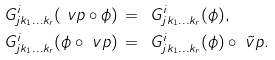<formula> <loc_0><loc_0><loc_500><loc_500>& \ G ^ { i } _ { j k _ { 1 } \dots k _ { r } } ( \ v p \circ \phi ) \, = \, \ G ^ { i } _ { j k _ { 1 } \dots k _ { r } } ( \phi ) , \\ & \ G ^ { i } _ { j k _ { 1 } \dots k _ { r } } ( \phi \circ \ v p ) \, = \, \ G ^ { i } _ { j k _ { 1 } \dots k _ { r } } ( \phi ) \circ \tilde { \ v p } .</formula> 